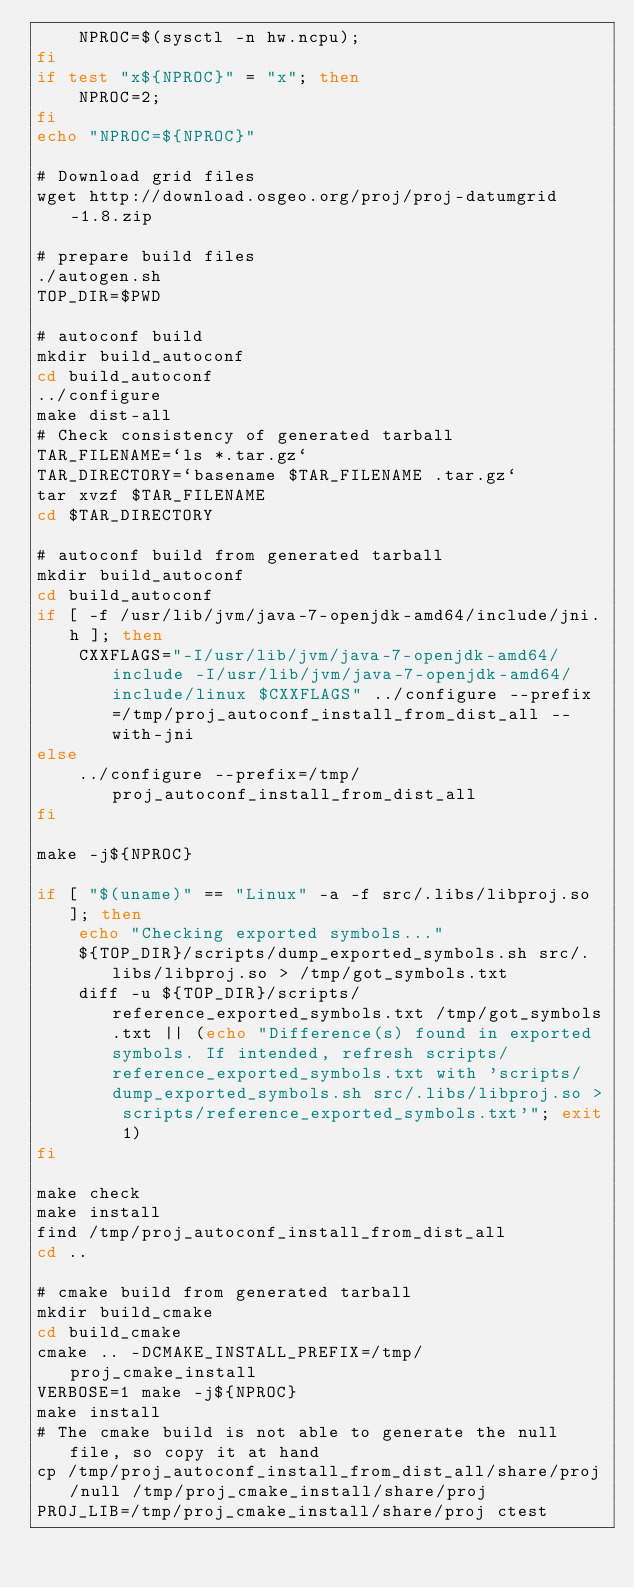Convert code to text. <code><loc_0><loc_0><loc_500><loc_500><_Bash_>    NPROC=$(sysctl -n hw.ncpu);
fi
if test "x${NPROC}" = "x"; then
    NPROC=2;
fi
echo "NPROC=${NPROC}"

# Download grid files
wget http://download.osgeo.org/proj/proj-datumgrid-1.8.zip

# prepare build files
./autogen.sh
TOP_DIR=$PWD

# autoconf build
mkdir build_autoconf
cd build_autoconf
../configure
make dist-all
# Check consistency of generated tarball
TAR_FILENAME=`ls *.tar.gz`
TAR_DIRECTORY=`basename $TAR_FILENAME .tar.gz`
tar xvzf $TAR_FILENAME
cd $TAR_DIRECTORY

# autoconf build from generated tarball
mkdir build_autoconf
cd build_autoconf
if [ -f /usr/lib/jvm/java-7-openjdk-amd64/include/jni.h ]; then
    CXXFLAGS="-I/usr/lib/jvm/java-7-openjdk-amd64/include -I/usr/lib/jvm/java-7-openjdk-amd64/include/linux $CXXFLAGS" ../configure --prefix=/tmp/proj_autoconf_install_from_dist_all --with-jni
else
    ../configure --prefix=/tmp/proj_autoconf_install_from_dist_all
fi

make -j${NPROC}

if [ "$(uname)" == "Linux" -a -f src/.libs/libproj.so ]; then
    echo "Checking exported symbols..."
    ${TOP_DIR}/scripts/dump_exported_symbols.sh src/.libs/libproj.so > /tmp/got_symbols.txt
    diff -u ${TOP_DIR}/scripts/reference_exported_symbols.txt /tmp/got_symbols.txt || (echo "Difference(s) found in exported symbols. If intended, refresh scripts/reference_exported_symbols.txt with 'scripts/dump_exported_symbols.sh src/.libs/libproj.so > scripts/reference_exported_symbols.txt'"; exit 1)
fi

make check
make install
find /tmp/proj_autoconf_install_from_dist_all
cd ..

# cmake build from generated tarball
mkdir build_cmake
cd build_cmake
cmake .. -DCMAKE_INSTALL_PREFIX=/tmp/proj_cmake_install
VERBOSE=1 make -j${NPROC}
make install
# The cmake build is not able to generate the null file, so copy it at hand
cp /tmp/proj_autoconf_install_from_dist_all/share/proj/null /tmp/proj_cmake_install/share/proj
PROJ_LIB=/tmp/proj_cmake_install/share/proj ctest</code> 